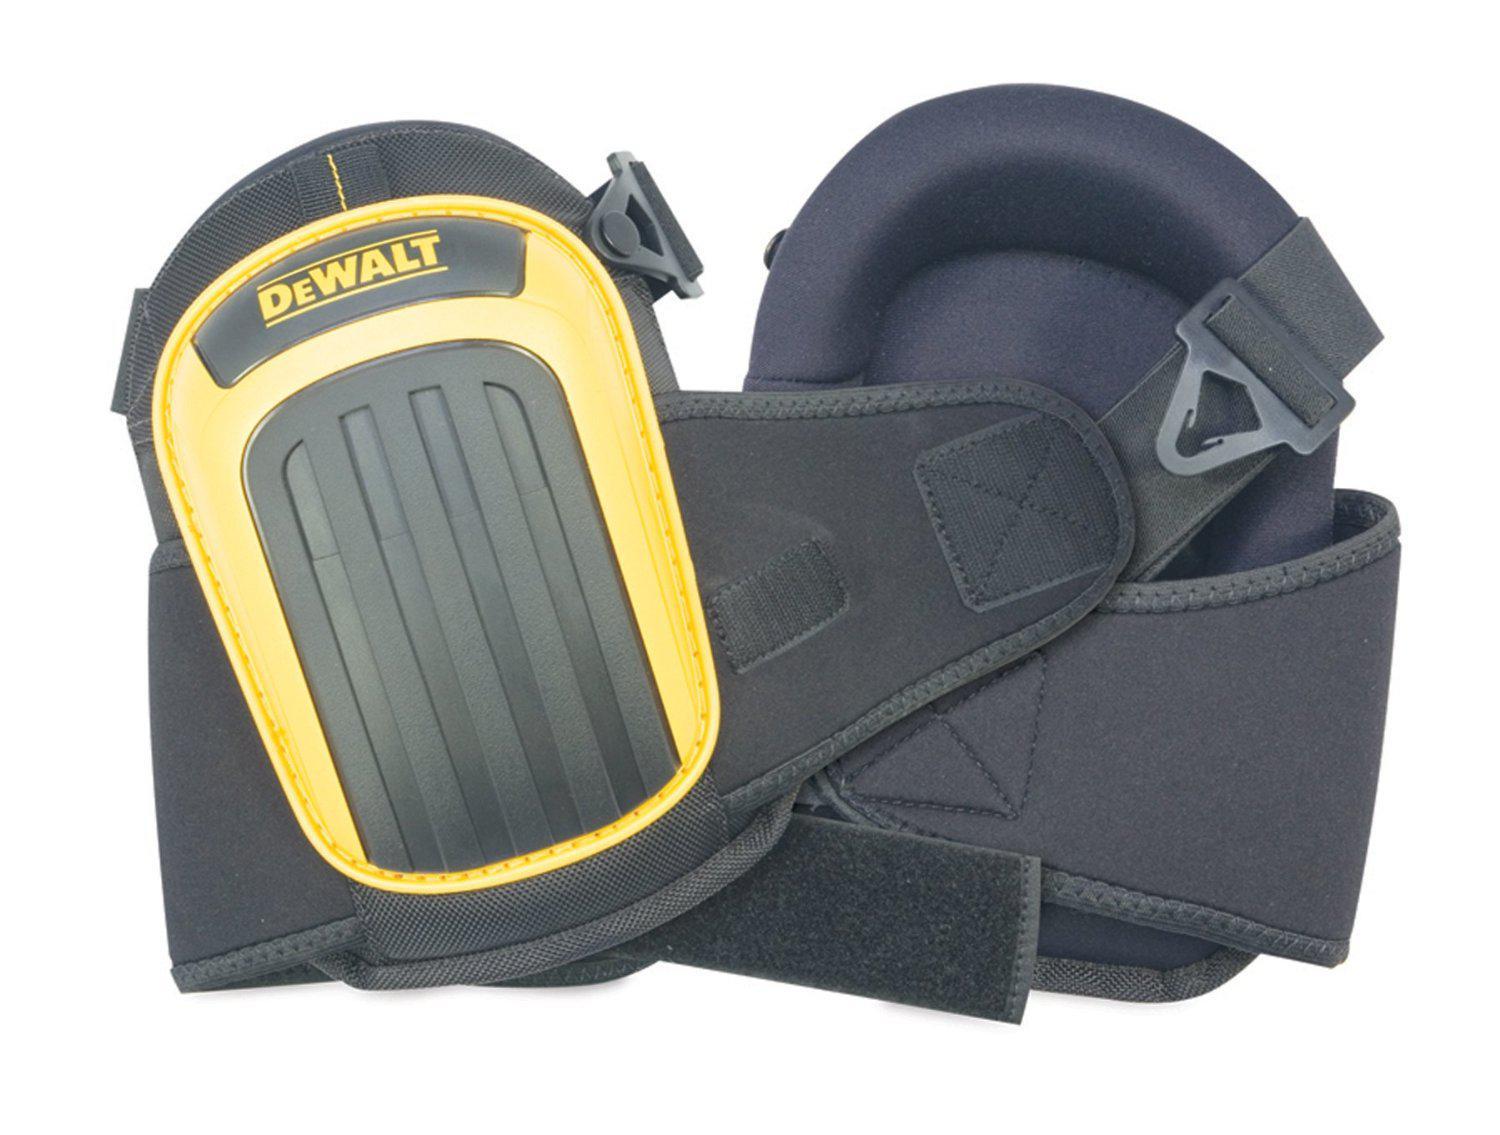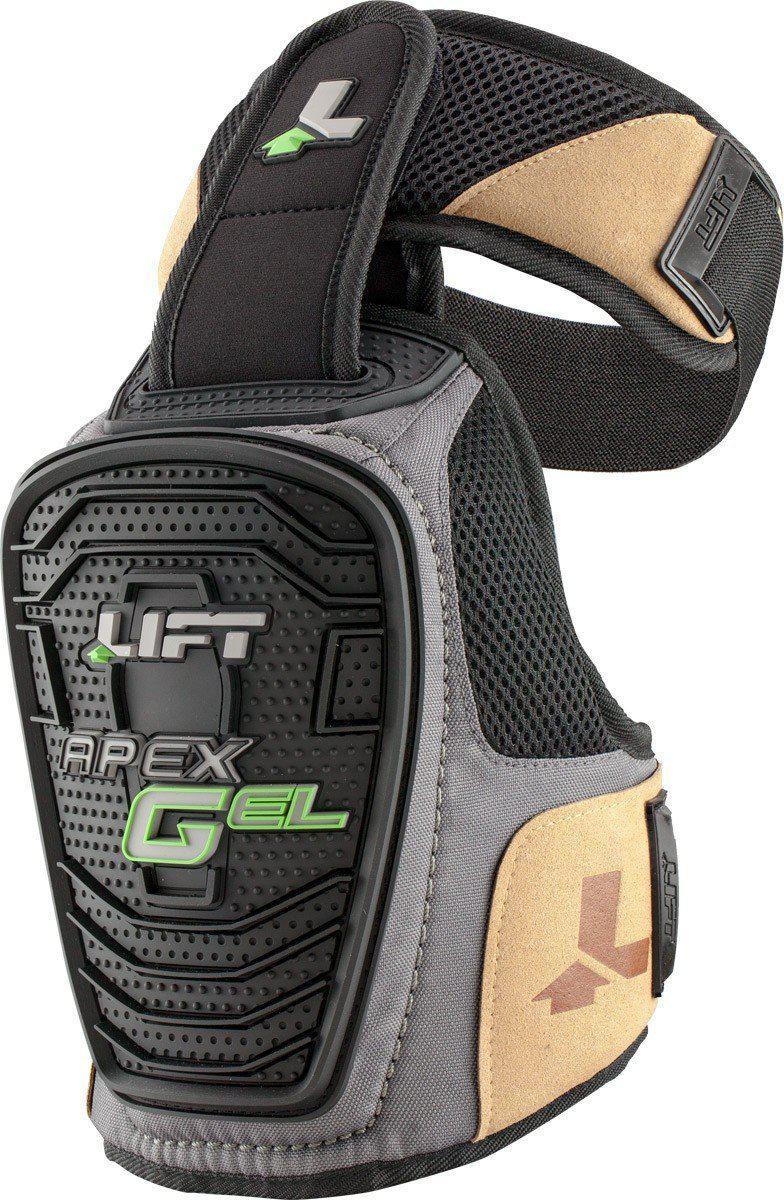The first image is the image on the left, the second image is the image on the right. For the images displayed, is the sentence "An image shows a pair of black knee pads with yellow trim on the front." factually correct? Answer yes or no. Yes. The first image is the image on the left, the second image is the image on the right. Evaluate the accuracy of this statement regarding the images: "At least one of the sets of knee pads is only yellow and grey.". Is it true? Answer yes or no. Yes. 